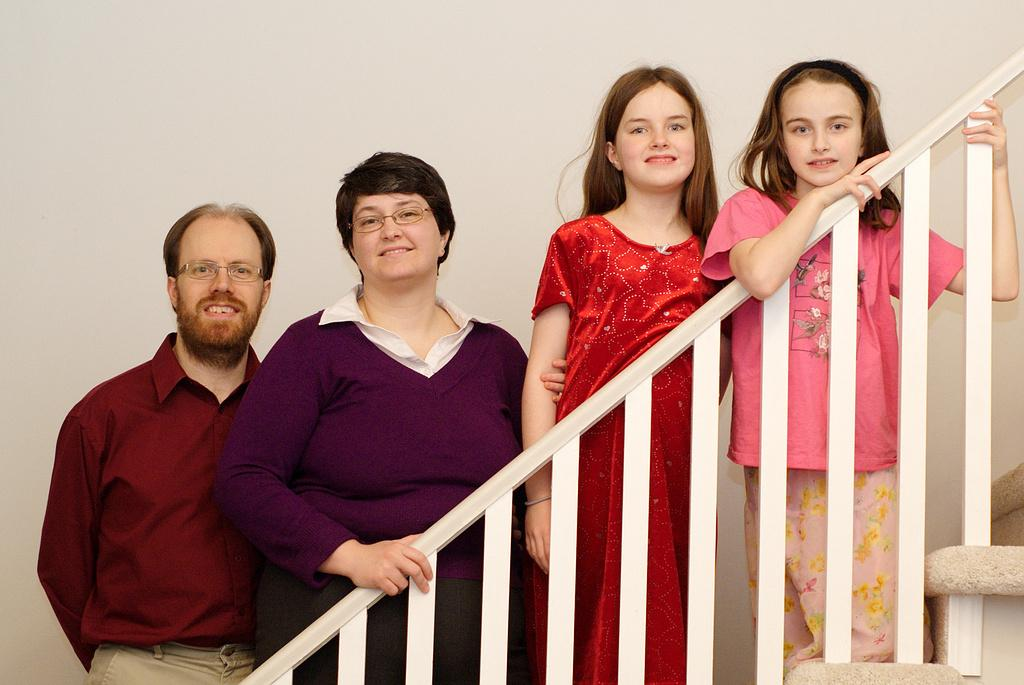How many people are in the image? There are four persons in the image. Where are the four persons located in the image? The four persons are standing on a staircase. What is visible behind the four persons? There is a wall behind the four persons. How many cakes are being served to the crowd in the image? There is no mention of cakes or a crowd in the image; it features four persons standing on a staircase with a wall behind them. 